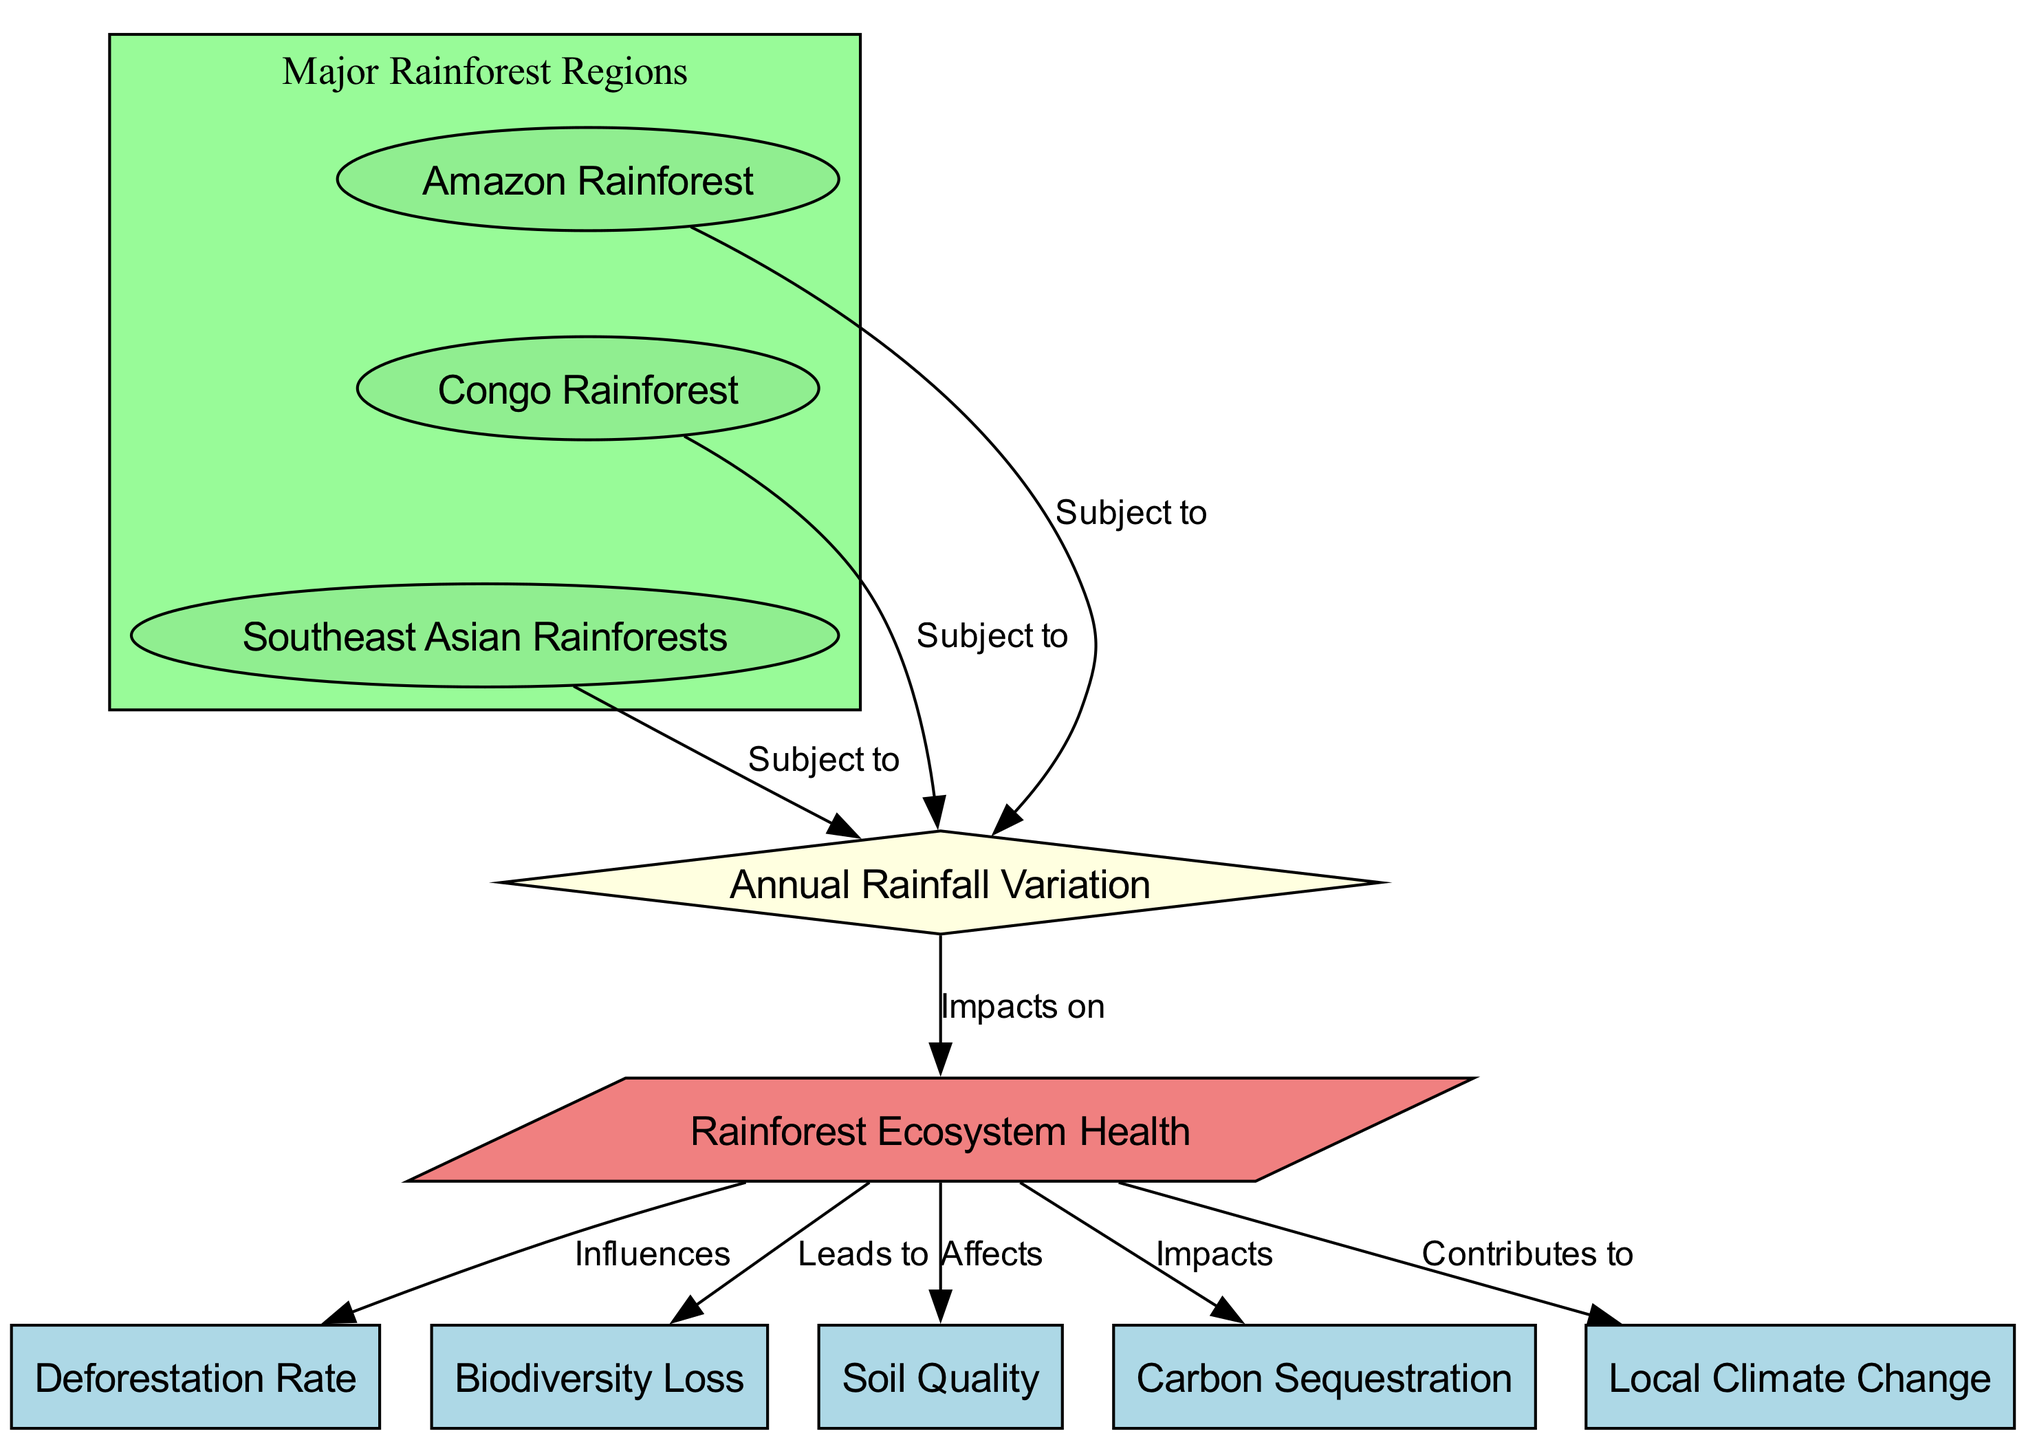What is the primary node that impacts rainforest ecosystem health? The diagram indicates that "Annual Rainfall Variation" has a direct impact on "Rainforest Ecosystem Health," which is represented by an edge labeled "Impacts on" connecting these two nodes.
Answer: Annual Rainfall Variation How many major rainforest regions are subject to rainfall variation? The diagram shows three major rainforest regions: "Amazon Rainforest," "Congo Rainforest," and "Southeast Asian Rainforests," each of which is connected to the "Annual Rainfall Variation" node with an edge labeled "Subject to."
Answer: Three What factor leads to biodiversity loss related to rainforest ecosystem health? According to the diagram, "Rainforest Ecosystem Health" influences "Biodiversity Loss," as indicated by an edge labeled "Leads to." This shows a direct relationship where the health of the rainforest is crucial for maintaining biodiversity.
Answer: Rainforest Ecosystem Health Which node is affected by rainforest ecosystem health when it comes to carbon sequestration? The diagram specifies that "Rainforest Ecosystem Health" has an impact on "Carbon Sequestration," indicated by the edge labeled "Impacts." Thus, the health of the rainforest directly affects its ability to sequester carbon.
Answer: Carbon Sequestration How does rainforest ecosystem health contribute to local climate change? The diagram illustrates that "Rainforest Ecosystem Health" contributes to "Local Climate Change," as shown by the edge labeled "Contributes to." Hence, the condition of the rainforest ecosystems plays a significant role in local climate dynamics.
Answer: Local Climate Change What is the relationship between rainforest ecosystem health and deforestation rate? The diagram shows that "Rainforest Ecosystem Health" influences the "Deforestation Rate," with the edge labeled "Influences." This demonstrates that healthier ecosystems are less likely to experience high deforestation rates.
Answer: Influences What is the shape of the node representing annual rainfall variation? In the diagram, "Annual Rainfall Variation" is represented as a diamond-shaped node, which is distinctive and indicates its role as a key factor in the overall ecosystem analysis.
Answer: Diamond Which node is primarily responsible for affecting soil quality? The diagram indicates that "Rainforest Ecosystem Health" affects "Soil Quality," as indicated by the edge labeled "Affects." Therefore, the health of the rainforest has a direct correlation with the quality of the soil within these ecosystems.
Answer: Soil Quality 